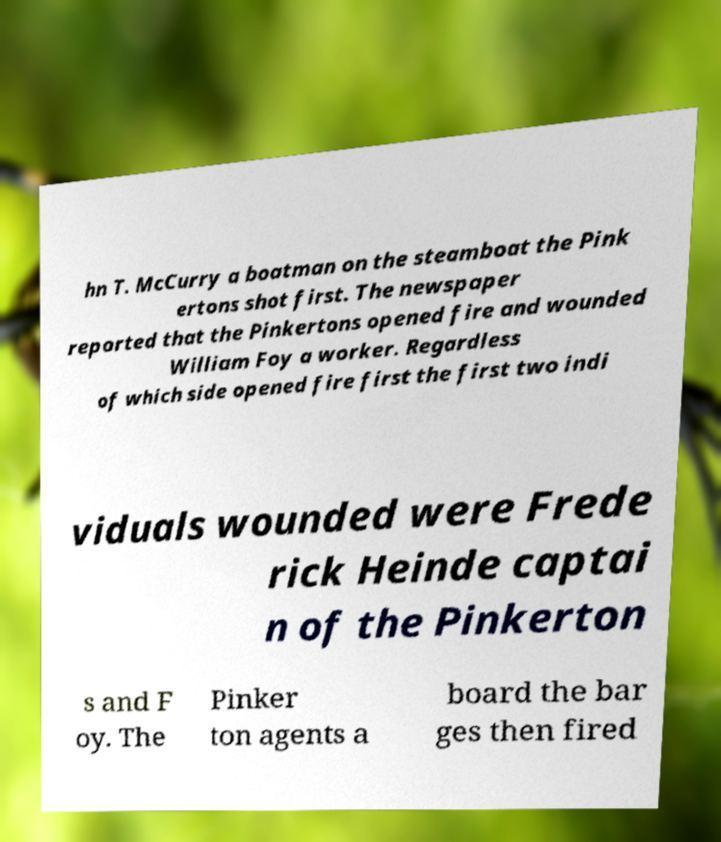For documentation purposes, I need the text within this image transcribed. Could you provide that? hn T. McCurry a boatman on the steamboat the Pink ertons shot first. The newspaper reported that the Pinkertons opened fire and wounded William Foy a worker. Regardless of which side opened fire first the first two indi viduals wounded were Frede rick Heinde captai n of the Pinkerton s and F oy. The Pinker ton agents a board the bar ges then fired 